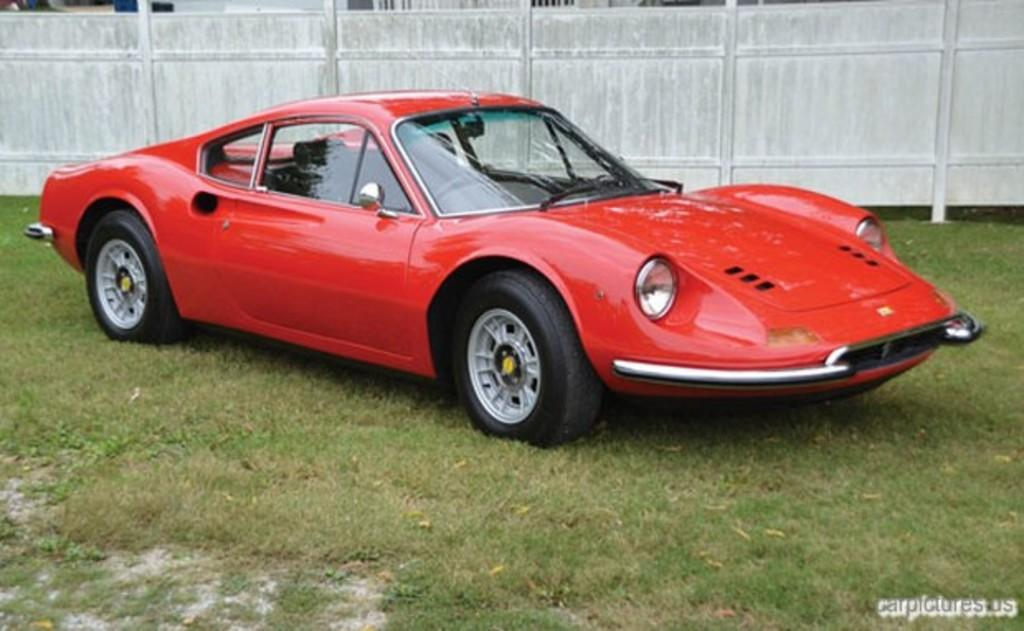What is the main subject of the image? The main subject of the image is a car on a grassland. What can be seen in the background of the image? There is a wooden wall in the background of the image. Is there any text present in the image? Yes, there is text in the bottom right corner of the image. What type of cloth is draped over the car in the image? There is no cloth draped over the car in the image; it is a car on a grassland with a wooden wall in the background and text in the bottom right corner. 